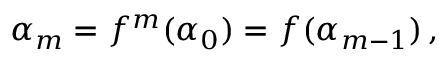Convert formula to latex. <formula><loc_0><loc_0><loc_500><loc_500>\alpha _ { m } = f ^ { m } ( \alpha _ { 0 } ) = f ( \alpha _ { m - 1 } ) \, ,</formula> 